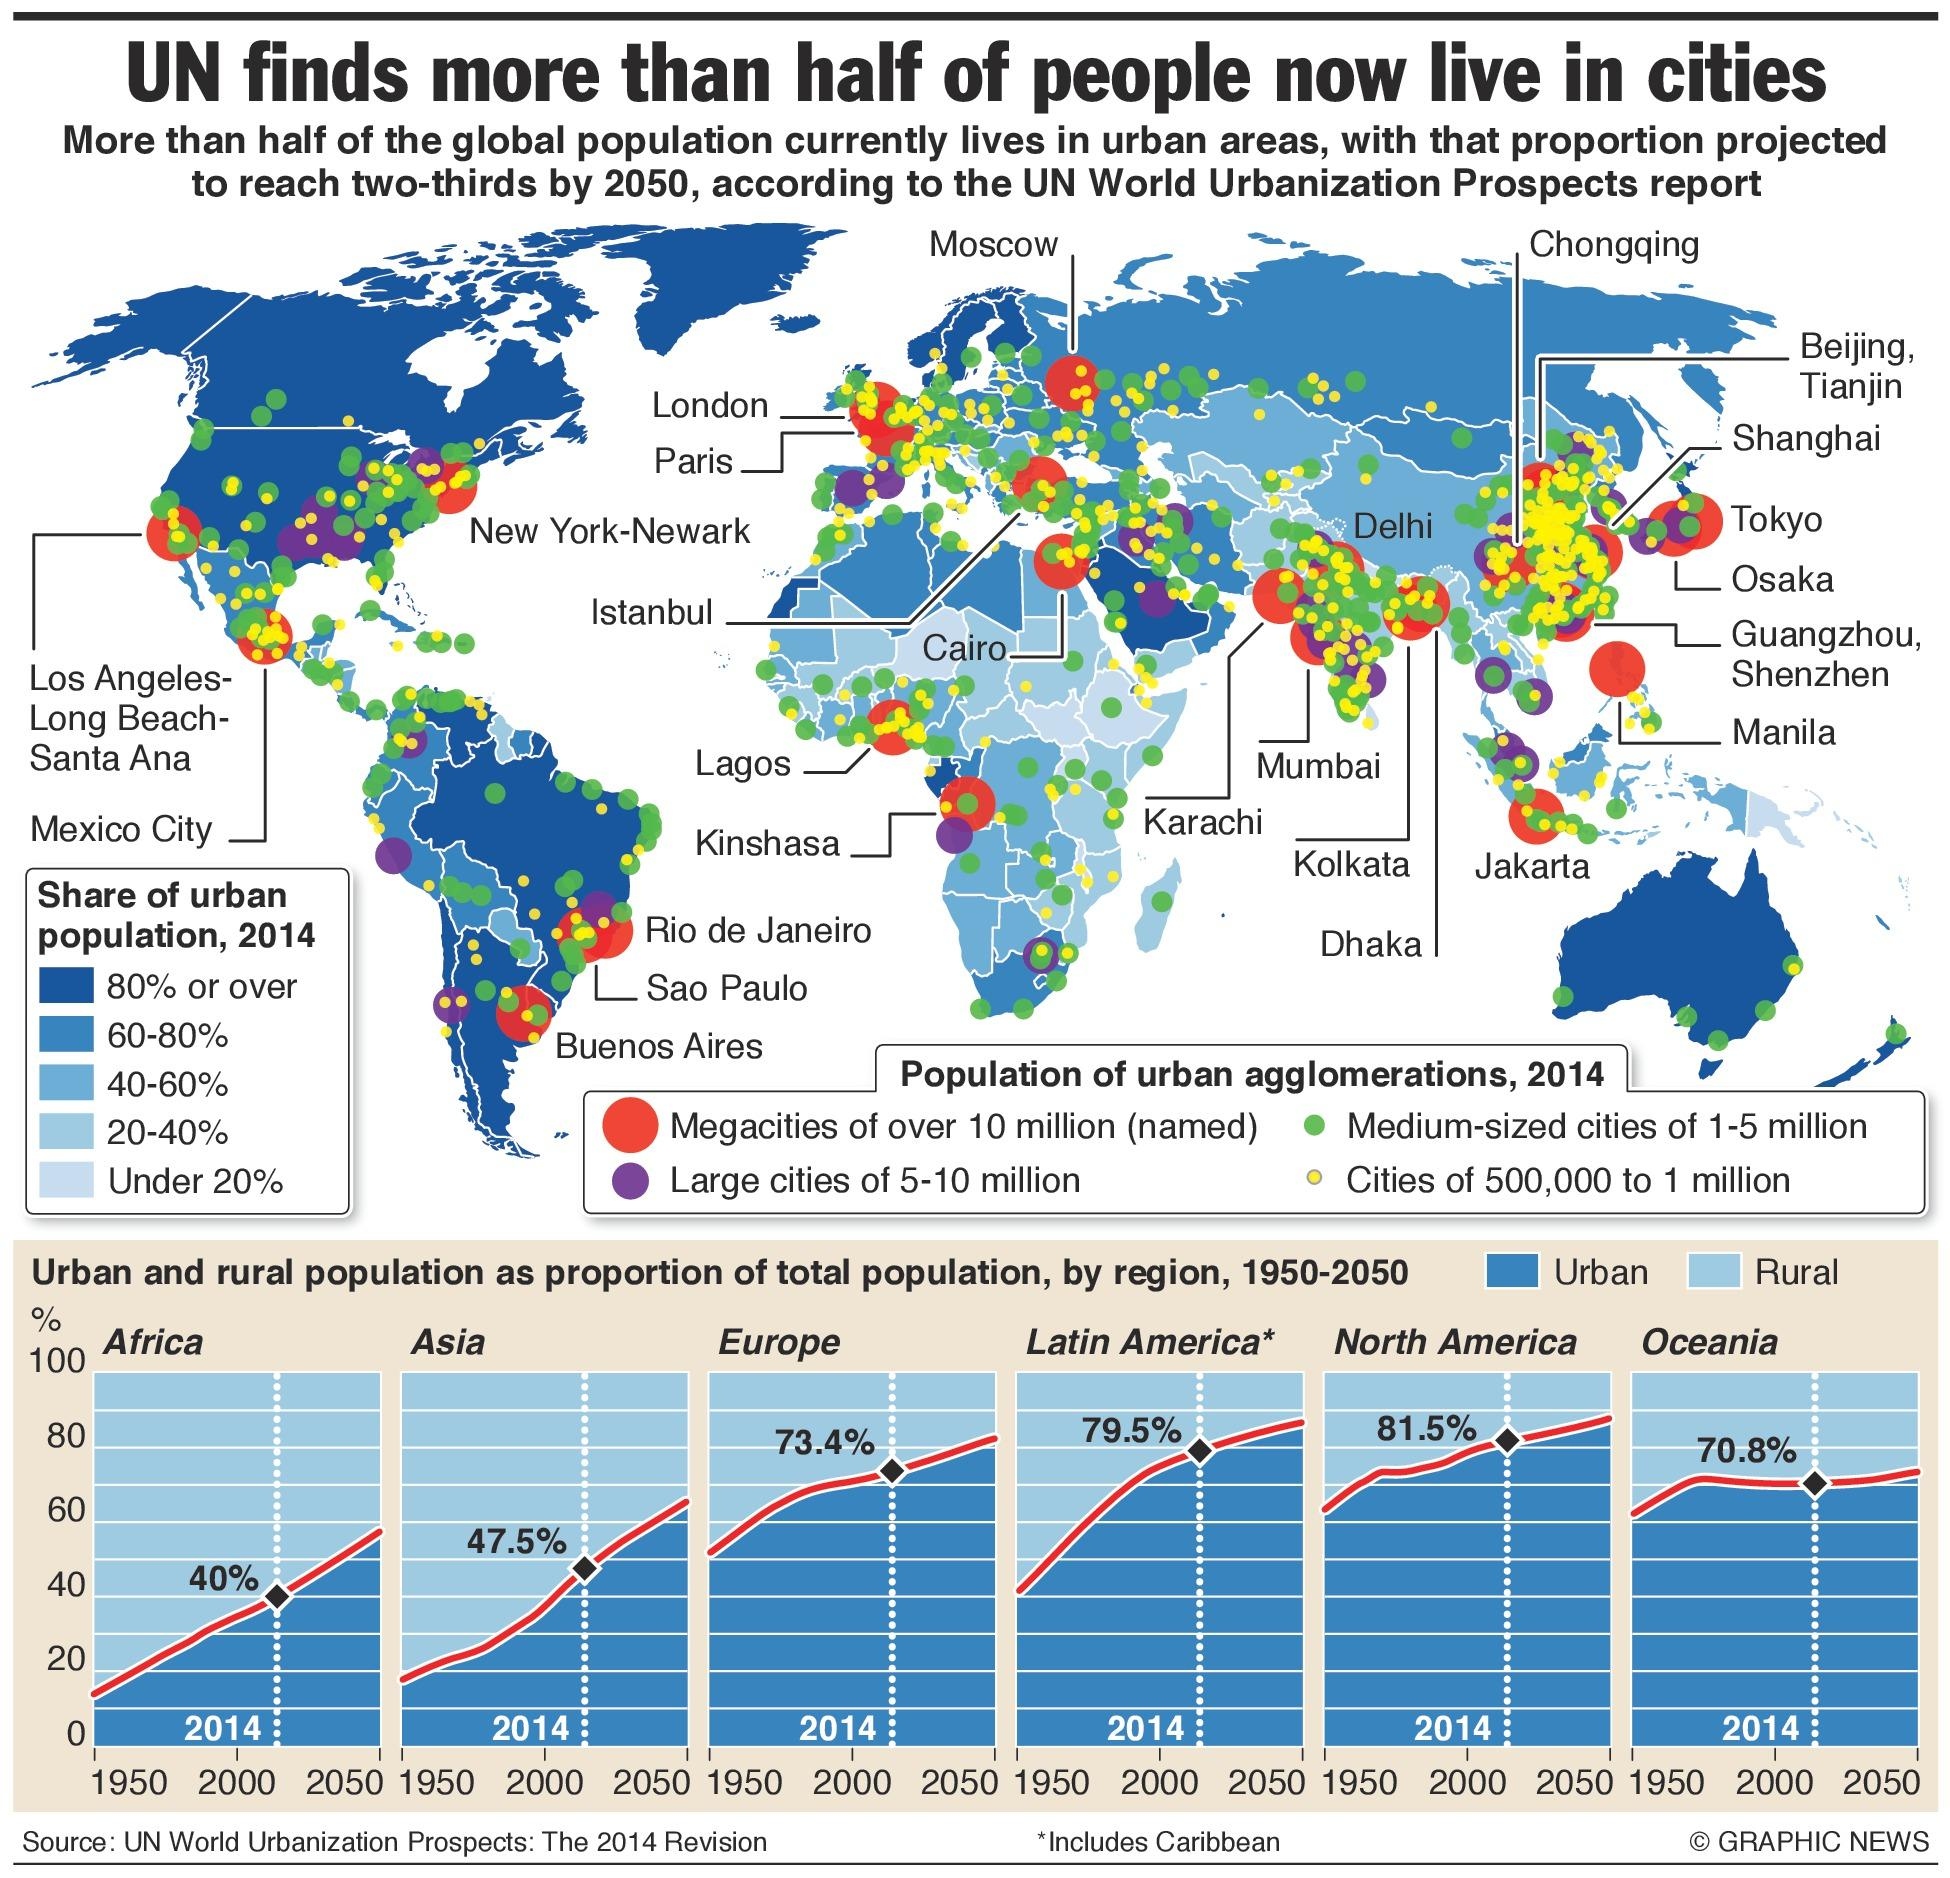List a handful of essential elements in this visual. In Australia, approximately 80% or more of the urban population is predominantly concentrated in urban areas. In the USA, approximately 80% of the urban population is predominantly located in cities. 